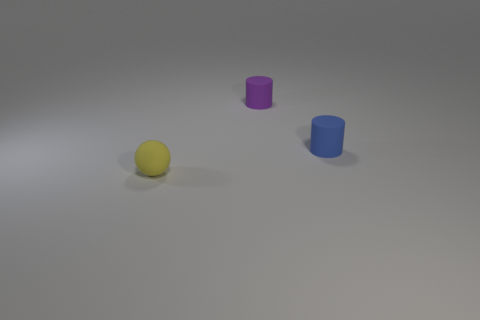How many other objects are there of the same size as the blue matte object?
Provide a succinct answer. 2. There is a blue cylinder; how many yellow matte spheres are in front of it?
Your answer should be compact. 1. How big is the purple thing?
Provide a succinct answer. Small. Do the tiny blue cylinder that is right of the purple thing and the thing in front of the tiny blue cylinder have the same material?
Give a very brief answer. Yes. Is there a tiny rubber object that has the same color as the sphere?
Provide a short and direct response. No. The matte cylinder that is the same size as the purple matte object is what color?
Your answer should be very brief. Blue. Is the color of the rubber object that is behind the small blue rubber thing the same as the tiny matte ball?
Provide a succinct answer. No. Is there a purple cylinder that has the same material as the small purple object?
Ensure brevity in your answer.  No. Is the number of purple matte cylinders that are to the right of the purple rubber thing less than the number of purple matte cylinders?
Make the answer very short. Yes. Do the cylinder in front of the purple object and the small purple rubber object have the same size?
Make the answer very short. Yes. 